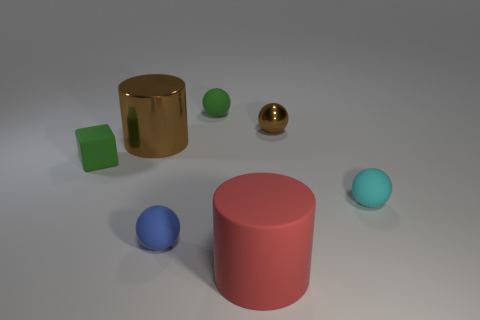Add 2 cylinders. How many objects exist? 9 Subtract all balls. How many objects are left? 3 Add 3 cyan things. How many cyan things exist? 4 Subtract 0 yellow cylinders. How many objects are left? 7 Subtract all big brown objects. Subtract all big brown metal cylinders. How many objects are left? 5 Add 3 big matte cylinders. How many big matte cylinders are left? 4 